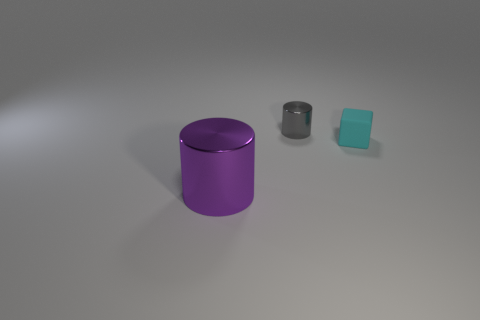Can you interpret the spacing of the objects? Does it suggest anything? The objects are spaced in a way that may suggest deliberate placement for compositional balance. The distances between them create a gradient of sizes that could be interpreted as an artistic arrangement or possibly to illustrate a size comparison or perspective. 